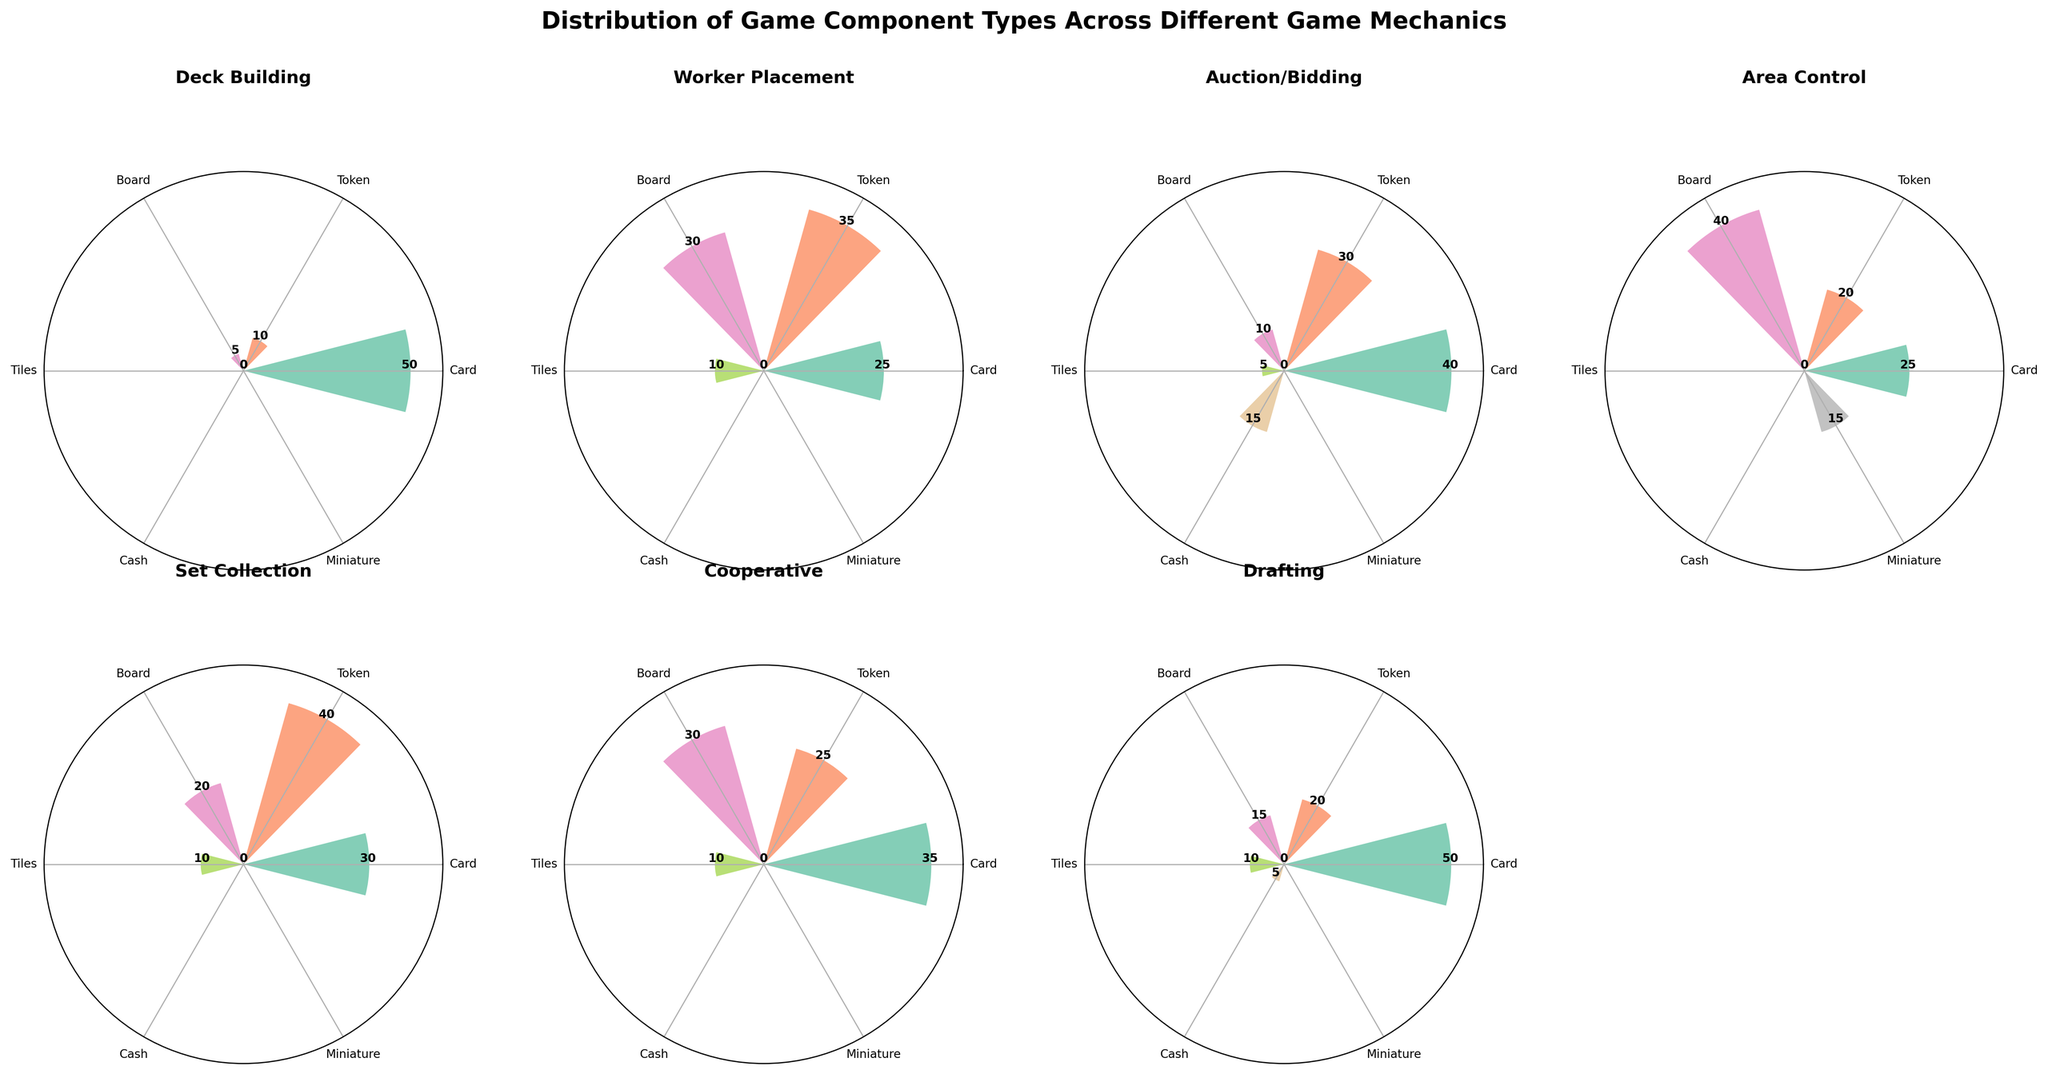what is the title of the chart? The title is often positioned at the top of the chart and summarizes what the chart is about. Here, the title "Distribution of Game Component Types Across Different Game Mechanics" specifies the content and focus of the rose charts.
Answer: Distribution of Game Component Types Across Different Game Mechanics Which game mechanic uses the highest number of card components? To find this, look at each subplot titled with different game mechanics and identify the bar with the highest value labeled "Card". The game mechanic subplot with the largest value is the answer.
Answer: Deck Building (Dominion) What is the least frequent component in the Set Collection game mechanic? Locate the subplot labeled "Set Collection" and find the component with the smallest bar or value.
Answer: Tiles How many different components are used in the Worker Placement game mechanic? Look at the subplot titled "Worker Placement" and count the different bars representing components.
Answer: Four Compare the frequency of the board component in the Cooperative and Area Control mechanics. Which one is higher? Identify the bars labeled "Board" in both the "Cooperative" and "Area Control" sublots and compare their heights or values.
Answer: Area Control What component has an equal frequency in both Auction/Bidding and Cooperative game mechanics? Look at each subplot and find a component with identical bar heights or values in both "Auction/Bidding" and "Cooperative".
Answer: Tiles Which game mechanics have a token frequency of 20 or more? Check each subplot for the "Token" component and identify subplots where the bar height or value is 20 or higher.
Answer: Deck Building, Worker Placement, Auction/Bidding, Set Collection, Drafting What is the total frequency of token components across all game mechanics? Sum up the values of the "Token" components from all subplots.
Answer: 180 Which game component is not used in the cooperative game mechanic? Look at the subplot for "Cooperative" and identify the component that has no bar or value assigned to it.
Answer: Miniature 